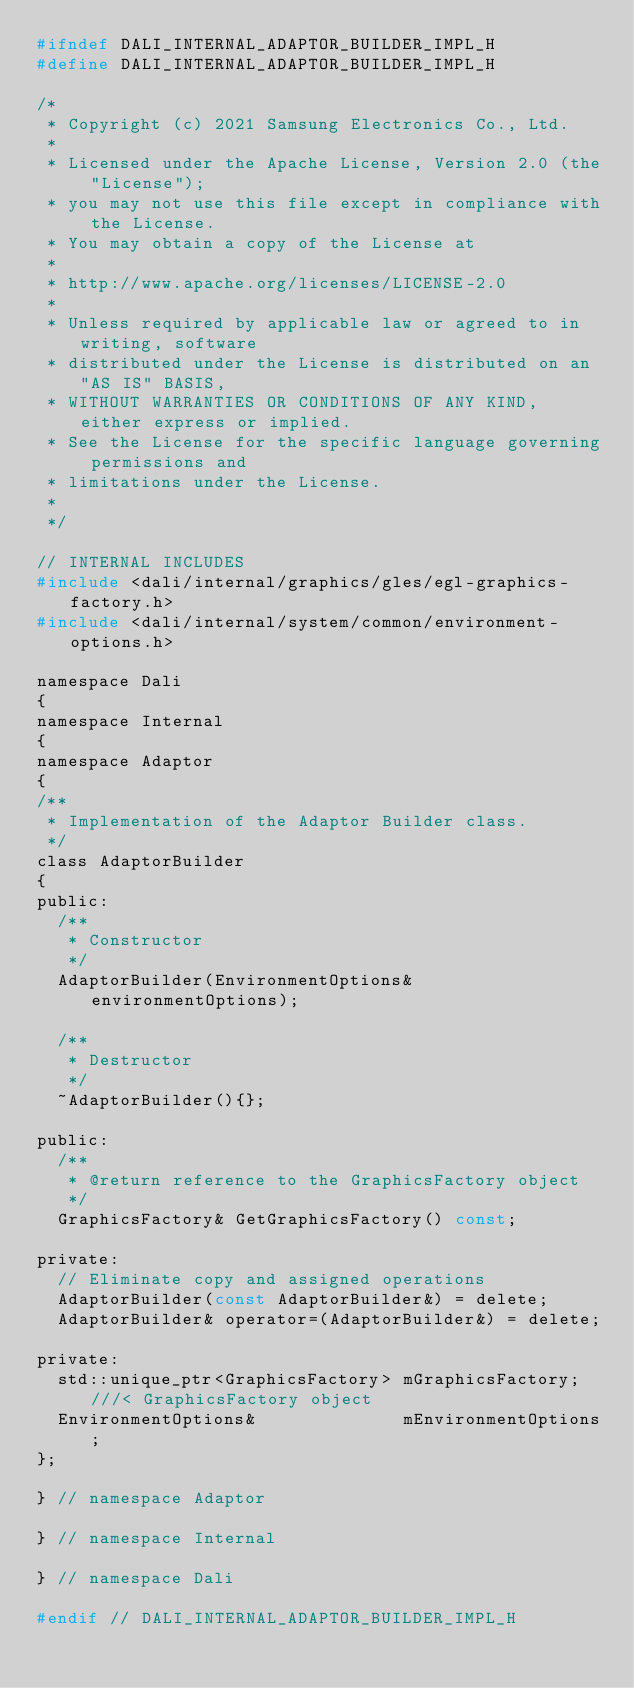<code> <loc_0><loc_0><loc_500><loc_500><_C_>#ifndef DALI_INTERNAL_ADAPTOR_BUILDER_IMPL_H
#define DALI_INTERNAL_ADAPTOR_BUILDER_IMPL_H

/*
 * Copyright (c) 2021 Samsung Electronics Co., Ltd.
 *
 * Licensed under the Apache License, Version 2.0 (the "License");
 * you may not use this file except in compliance with the License.
 * You may obtain a copy of the License at
 *
 * http://www.apache.org/licenses/LICENSE-2.0
 *
 * Unless required by applicable law or agreed to in writing, software
 * distributed under the License is distributed on an "AS IS" BASIS,
 * WITHOUT WARRANTIES OR CONDITIONS OF ANY KIND, either express or implied.
 * See the License for the specific language governing permissions and
 * limitations under the License.
 *
 */

// INTERNAL INCLUDES
#include <dali/internal/graphics/gles/egl-graphics-factory.h>
#include <dali/internal/system/common/environment-options.h>

namespace Dali
{
namespace Internal
{
namespace Adaptor
{
/**
 * Implementation of the Adaptor Builder class.
 */
class AdaptorBuilder
{
public:
  /**
   * Constructor
   */
  AdaptorBuilder(EnvironmentOptions& environmentOptions);

  /**
   * Destructor
   */
  ~AdaptorBuilder(){};

public:
  /**
   * @return reference to the GraphicsFactory object
   */
  GraphicsFactory& GetGraphicsFactory() const;

private:
  // Eliminate copy and assigned operations
  AdaptorBuilder(const AdaptorBuilder&) = delete;
  AdaptorBuilder& operator=(AdaptorBuilder&) = delete;

private:
  std::unique_ptr<GraphicsFactory> mGraphicsFactory; ///< GraphicsFactory object
  EnvironmentOptions&              mEnvironmentOptions;
};

} // namespace Adaptor

} // namespace Internal

} // namespace Dali

#endif // DALI_INTERNAL_ADAPTOR_BUILDER_IMPL_H
</code> 